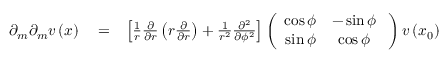Convert formula to latex. <formula><loc_0><loc_0><loc_500><loc_500>\begin{array} { r l r } { \partial _ { m } \partial _ { m } v \left ( x \right ) } & = } & { \left [ \frac { 1 } { r } \frac { \partial } { \partial r } \left ( r \frac { \partial } { \partial r } \right ) + \frac { 1 } { r ^ { 2 } } \frac { \partial ^ { 2 } } { \partial \phi ^ { 2 } } \right ] \left ( \begin{array} { c c } { \cos \phi } & { - \sin \phi } \\ { \sin \phi } & { \cos \phi } \end{array} \, \right ) v \left ( x _ { 0 } \right ) } \end{array}</formula> 